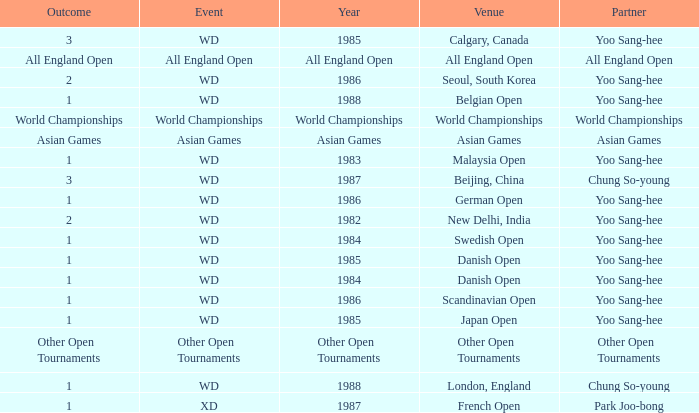What was the Outcome of the Danish Open in 1985? 1.0. 